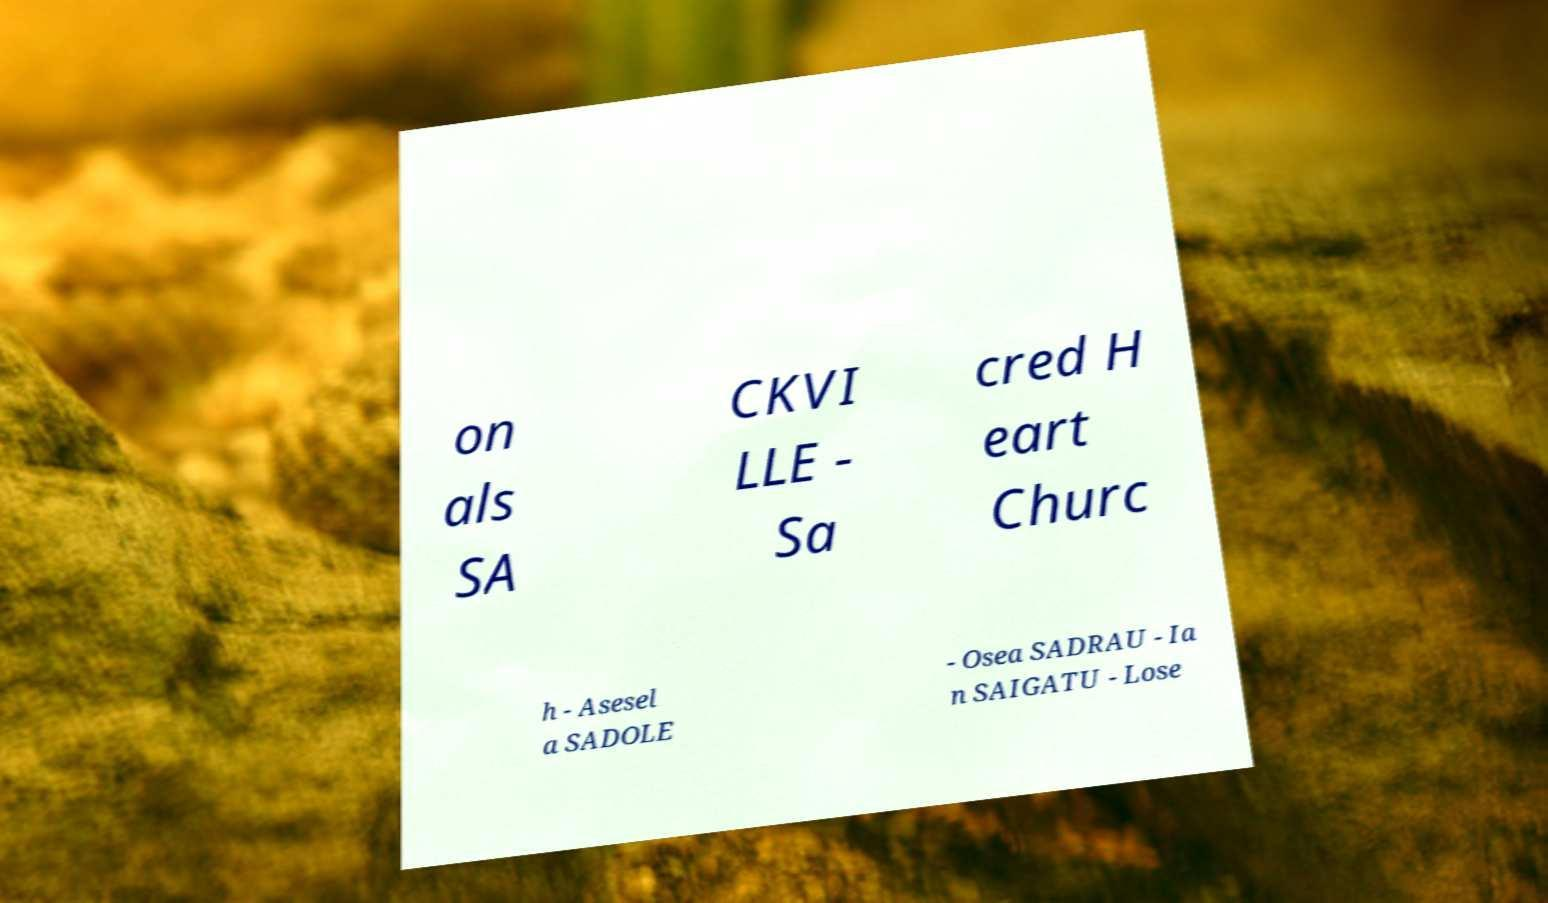Can you read and provide the text displayed in the image?This photo seems to have some interesting text. Can you extract and type it out for me? on als SA CKVI LLE - Sa cred H eart Churc h - Asesel a SADOLE - Osea SADRAU - Ia n SAIGATU - Lose 